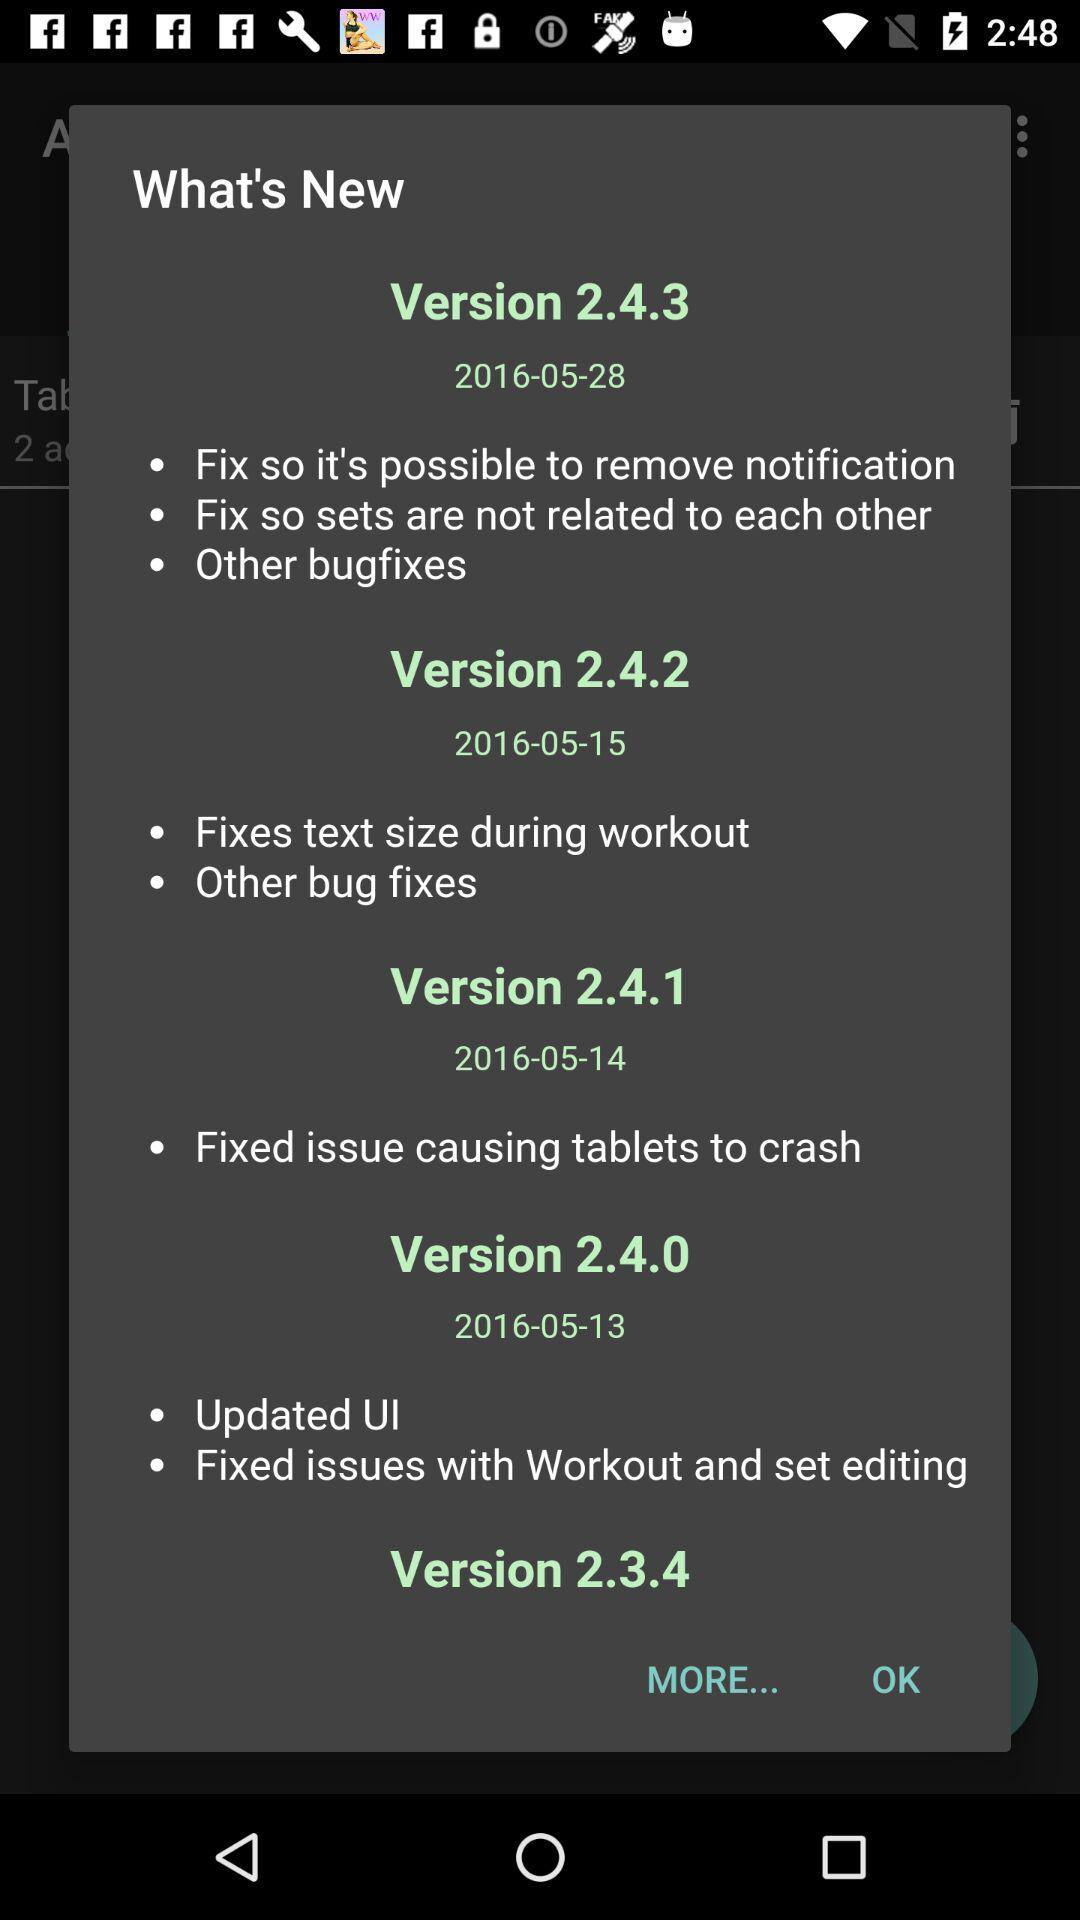How many versions of the app have been released since May 13th?
Answer the question using a single word or phrase. 4 